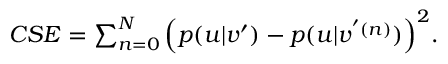<formula> <loc_0><loc_0><loc_500><loc_500>\begin{array} { r } { { C S E } = \sum _ { n = 0 } ^ { N } \left ( p ( u | v ^ { \prime } ) - p ( u | v ^ { ^ { \prime } ( n ) } ) \right ) ^ { 2 } . } \end{array}</formula> 